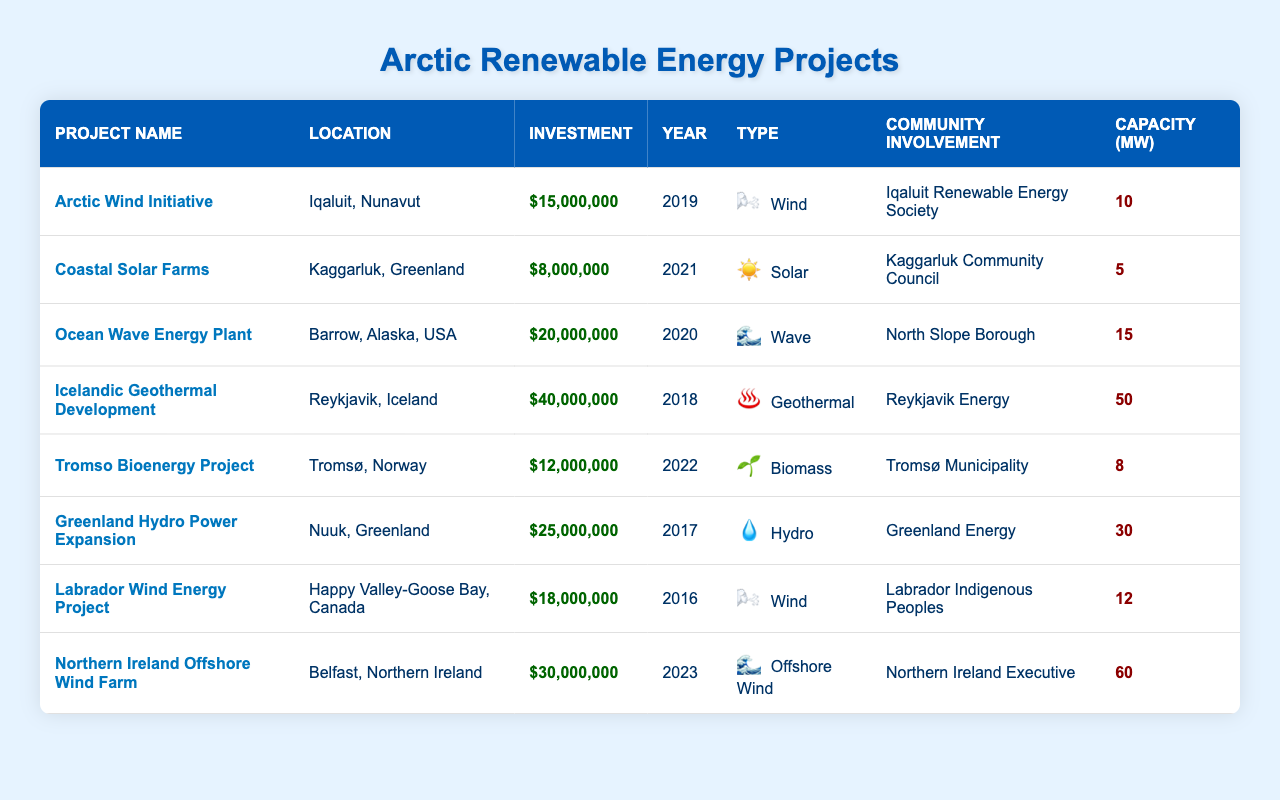What is the total investment in renewable energy projects listed in the table? To find the total investment, we add the amounts: 15000000 + 8000000 + 20000000 + 40000000 + 12000000 + 25000000 + 18000000 + 30000000 = 146000000.
Answer: 146000000 Which renewable energy project has the highest capacity? The project with the highest capacity is the "Icelandic Geothermal Development" with 50 MW. We check the capacity column to identify the maximum value.
Answer: Icelandic Geothermal Development How many wind energy projects are mentioned in the table? We count the projects of type "Wind": "Arctic Wind Initiative" and "Labrador Wind Energy Project", which gives us 2 wind energy projects.
Answer: 2 What is the average investment amount of the solar projects? The solar project is "Coastal Solar Farms" with an investment amount of 8000000. Since there's only one solar project, the average investment is also 8000000.
Answer: 8000000 Is there a project in the year 2021? Yes, "Coastal Solar Farms" was initiated in 2021. We look through the Year column to confirm.
Answer: Yes What is the total capacity of all wave energy projects in the table? There is one wave energy project: "Ocean Wave Energy Plant" with a capacity of 15 MW. Since there's only one, the total capacity is 15 MW.
Answer: 15 What percentage of the total investment is represented by the investment in geothermal projects? The investment in geothermal projects is 40000000. To find the percentage: (40000000/146000000) * 100 = 27.4%.
Answer: 27.4% Which location has the highest investment for a renewable energy project? The highest investment is found in "Icelandic Geothermal Development" located in Reykjavik, Iceland, which has 40000000. We compare the investment amounts of all projects to confirm.
Answer: Reykjavik, Iceland How many projects have community involvement from indigenous groups? There are two projects with indigenous involvement: "Labrador Wind Energy Project" and "Arctic Wind Initiative." We check the Community Involvement column to identify these.
Answer: 2 What is the difference in capacity between the highest and lowest capacity projects? The highest capacity project is "Icelandic Geothermal Development" at 50 MW and the lowest is "Coastal Solar Farms" at 5 MW. The difference is 50 - 5 = 45 MW.
Answer: 45 MW 